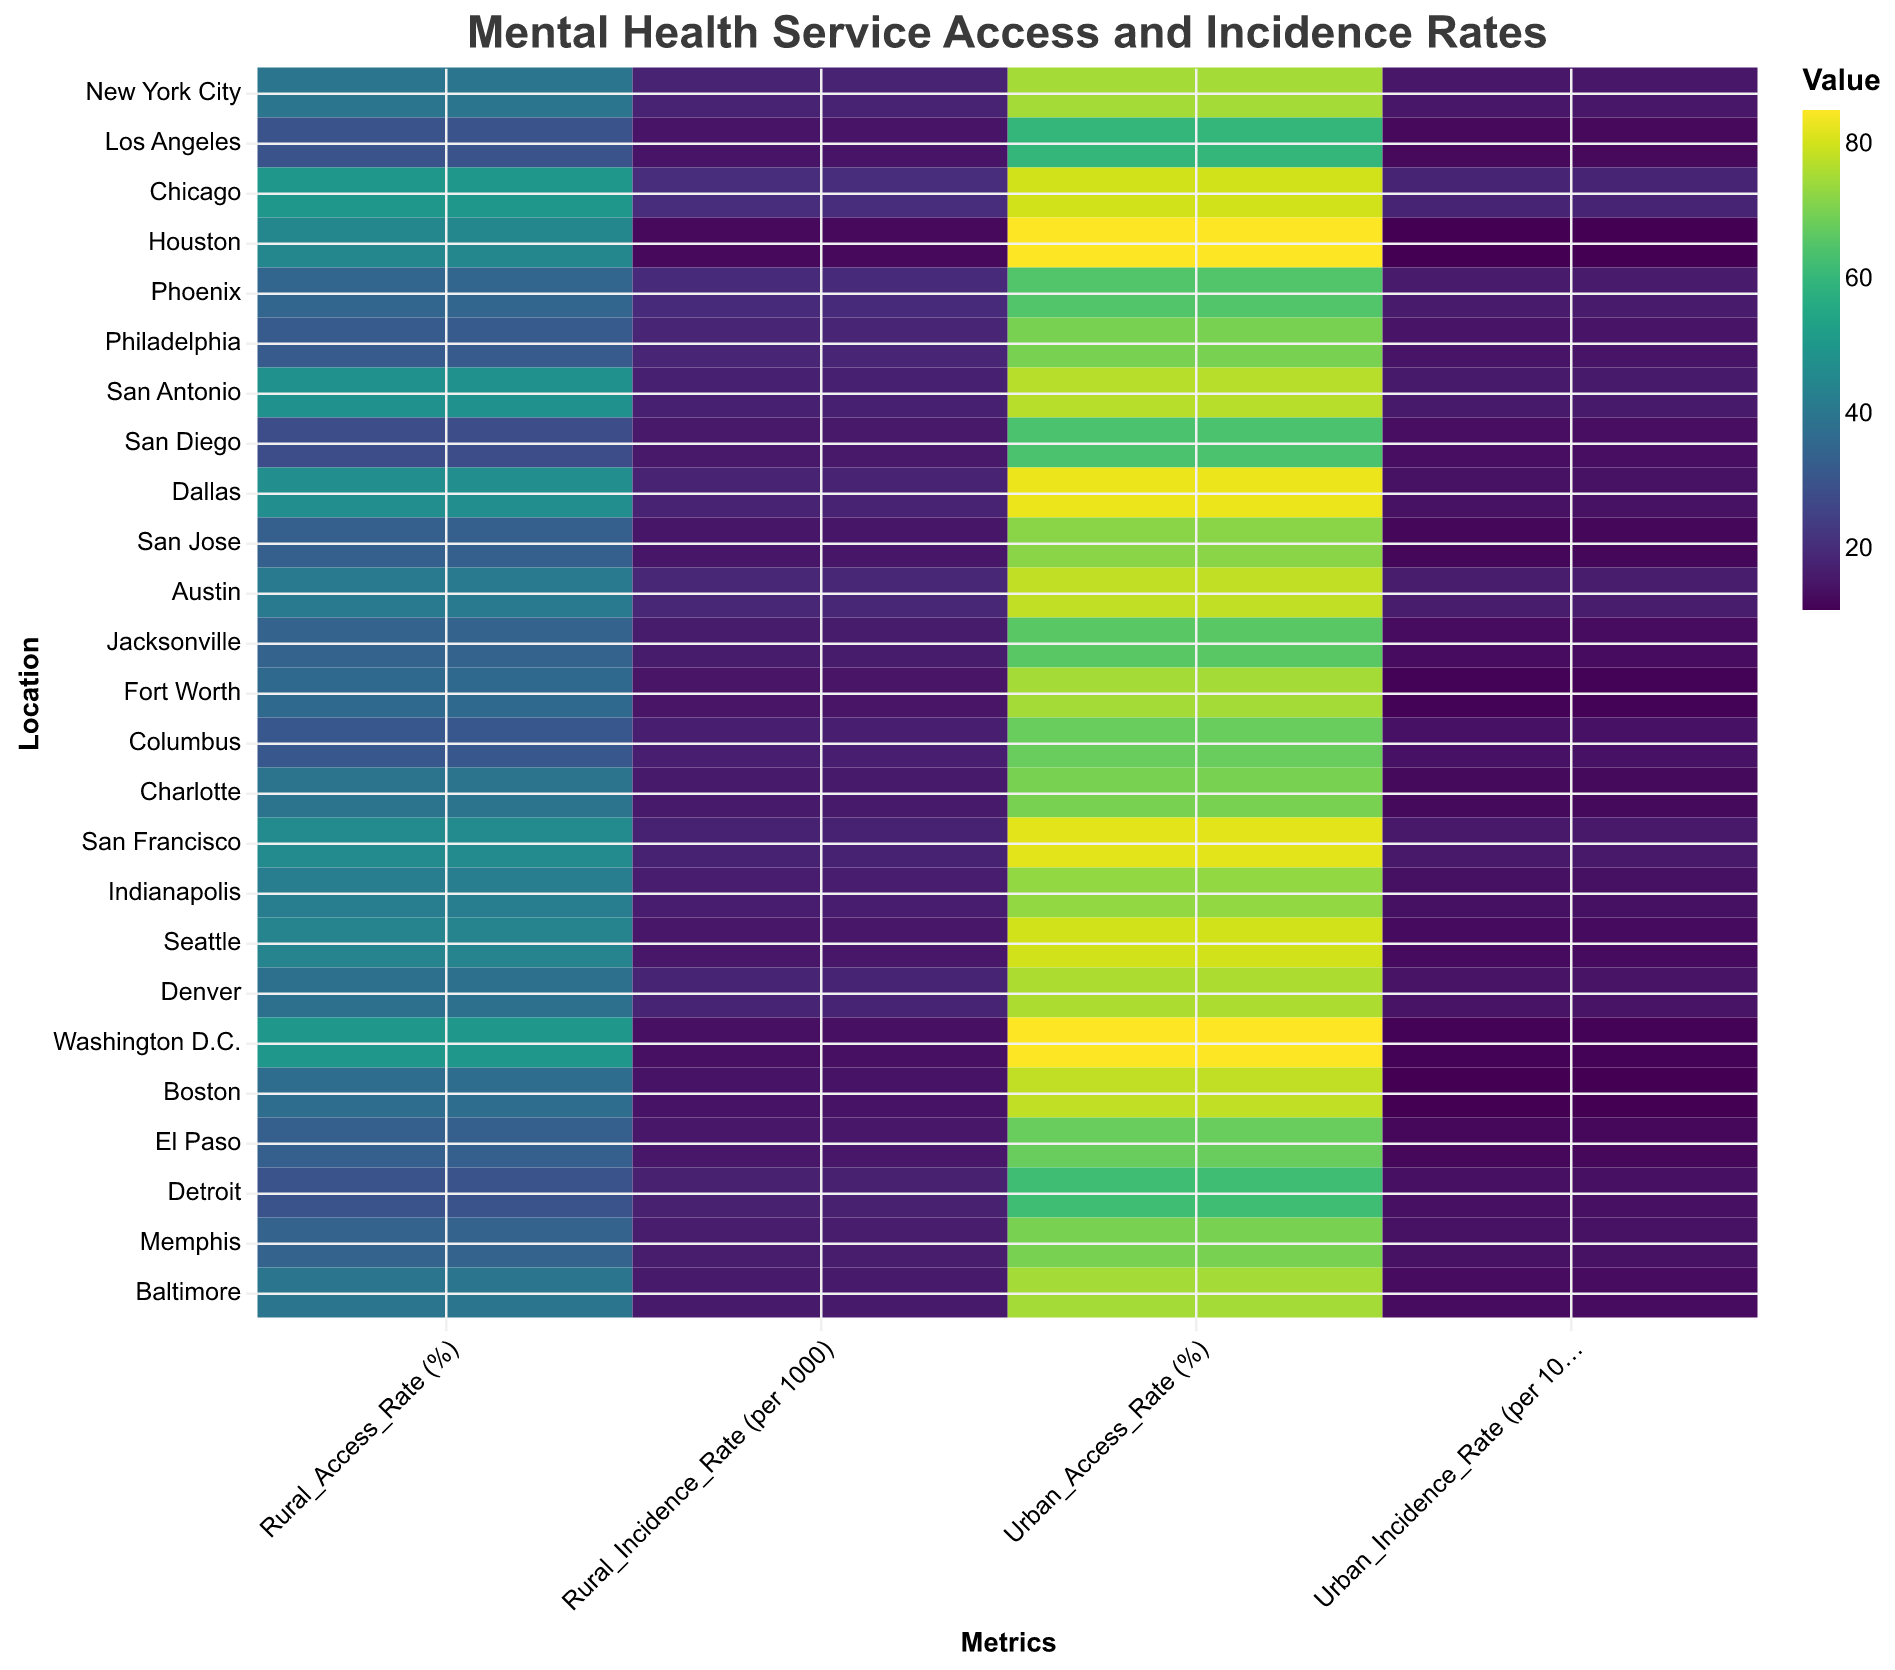What is the title of the heatmap? The title is located at the top of the figure and is usually the most prominent text. By observing this, we can read the exact title provided.
Answer: Mental Health Service Access and Incidence Rates How many locations are compared in the heatmap? By counting the number of unique locations listed on the y-axis, we can determine the number of locations compared.
Answer: 25 Which location has the highest urban access rate for emergency hotlines? Look for the "Emergency Hotlines" under "Service_Type" and find the corresponding Urban_Access_Rate (%). Houston has the highest urban access rate of 85.
Answer: Houston What is the difference in rural incidence rate between Phoenix and San Antonio? Find the Rural_Incidence_Rate (per 1000) for both Phoenix and San Antonio. The difference is calculated by subtracting the value for San Antonio from Phoenix (19.6 - 17.1).
Answer: 2.5 Which service type has the highest combined rural access rate across all locations? Sum the Rural_Access_Rate (%) for each Service_Type across all locations and compare the totals to find the highest one.
Answer: Telehealth Services Are the urban incidence rates generally higher or lower than the rural incidence rates? Compare the general trend by observing the color gradient differences between the Urban_Incidence_Rate and Rural_Incidence_Rate columns. Urban rates generally appear to be lower compared to rural rates.
Answer: Lower Which service has the least disparity in access rates between urban and rural areas in New York City? Look for New York City and compare the difference between Urban_Access_Rate (%) and Rural_Access_Rate (%) for the different services. The smallest difference indicates the least disparity.
Answer: Therapy Centers How does the urban access rate for school counseling in San Jose compare to the rural access rate for the same service in Los Angeles? Find "School Counseling" in San Jose's Urban_Access_Rate (%) and compare it against "Support Groups" in Los Angeles' Rural_Access_Rate (%). The rates are 72% for San Jose's urban area and 30% for Los Angeles' rural area.
Answer: Higher What is the average urban incidence rate across all locations? Sum all Urban_Incidence_Rate (per 1000) values from all locations and divide by the number of locations (25).
Answer: 13.9 Which city has the highest incidence rate in rural areas for trauma counseling, and what is the value? Find the location with the highest Rural_Incidence_Rate (per 1000) in the "Trauma Counseling" service type. Detroit has the highest value, 17.3.
Answer: Detroit, 17.3 